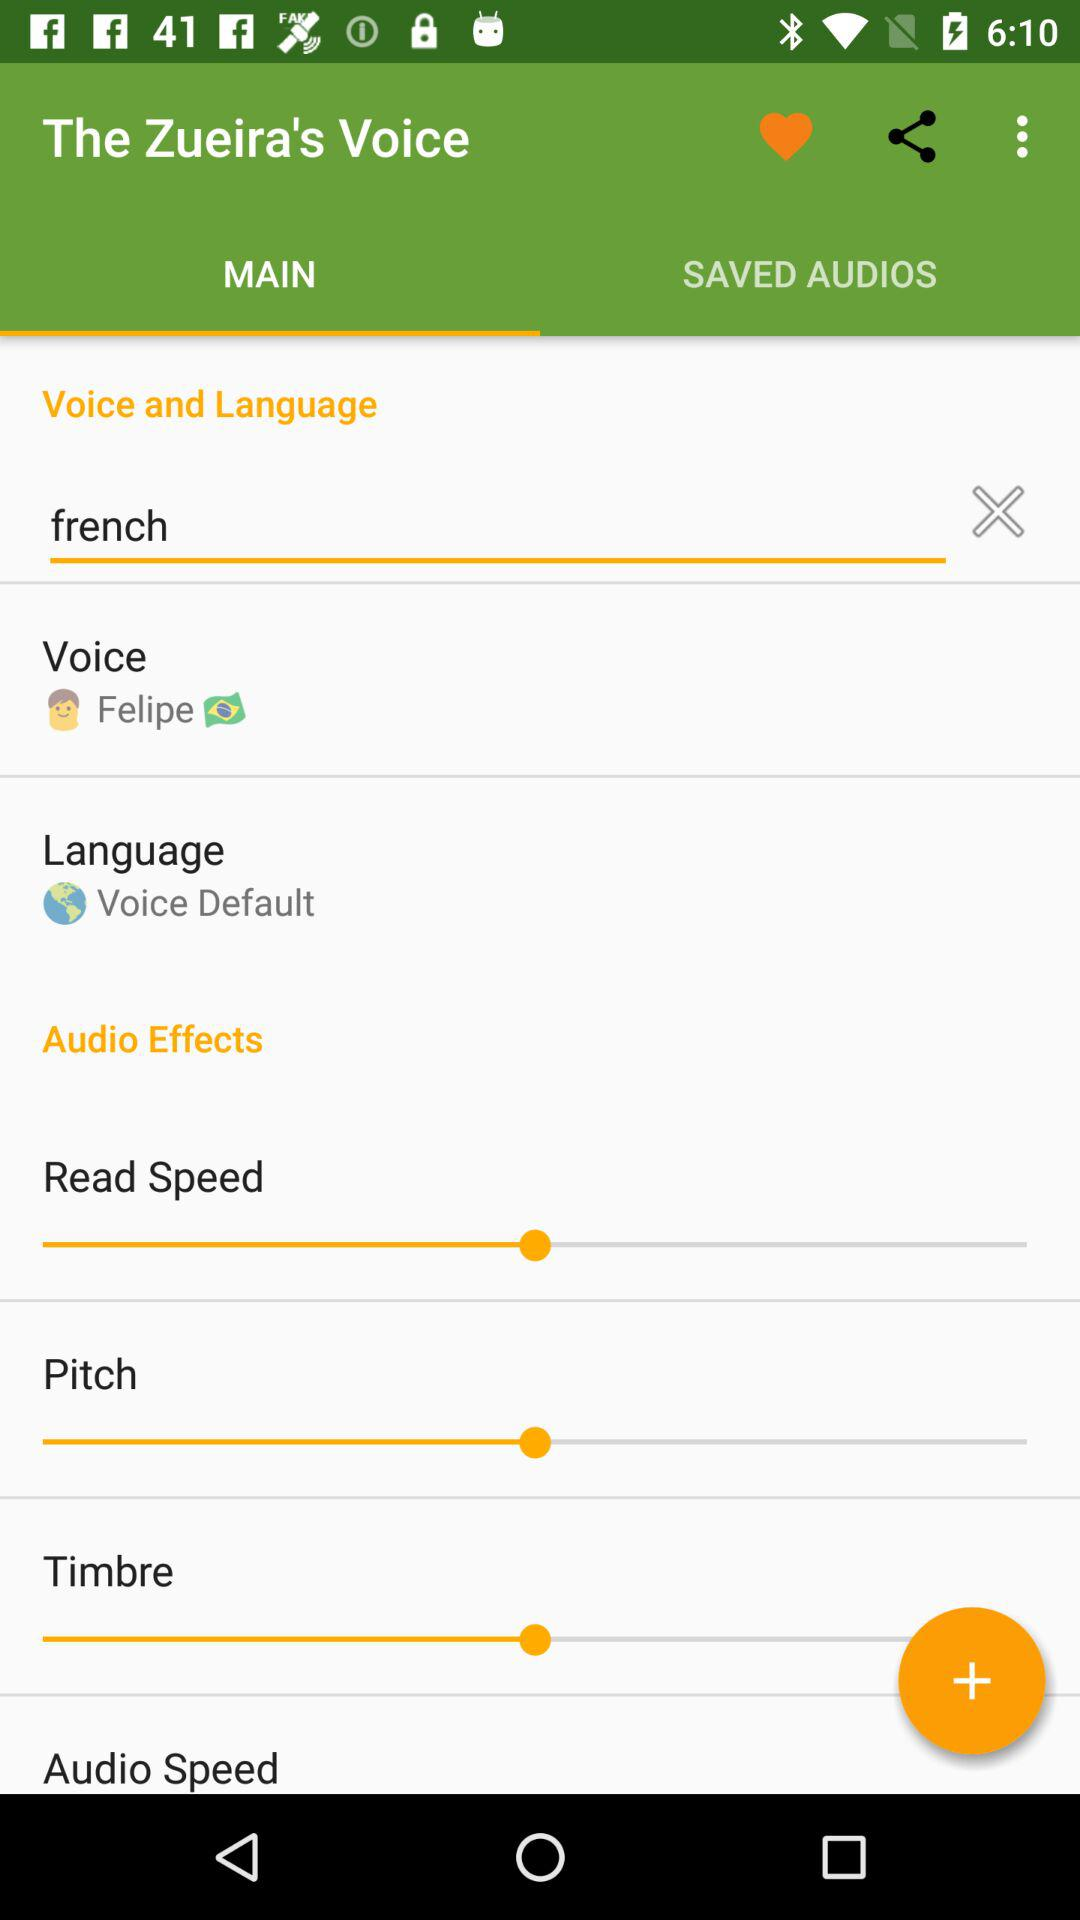How many audio effects are available?
Answer the question using a single word or phrase. 4 